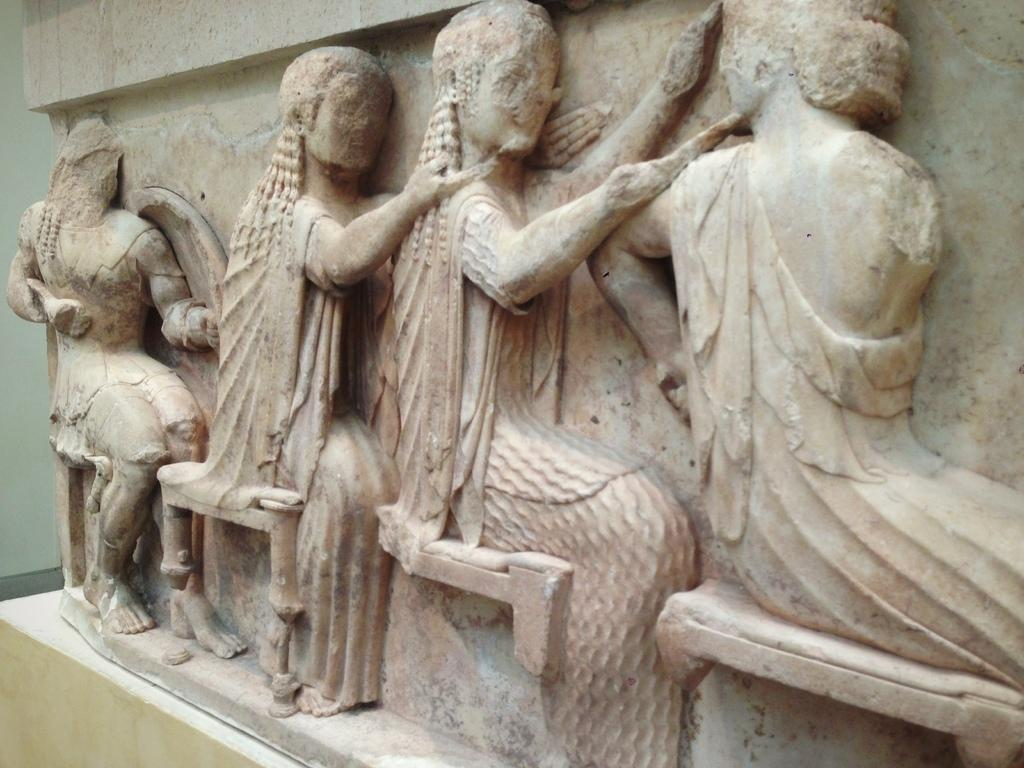What is located in the foreground of the image? There is a wall in the foreground of the image. What can be seen on the wall in the foreground? The wall has sculptures of people on it. What is visible in the background of the image? There is another wall in the background of the image. How many bricks are used to build the hen in the image? There is no hen present in the image, and therefore no bricks can be associated with it. 